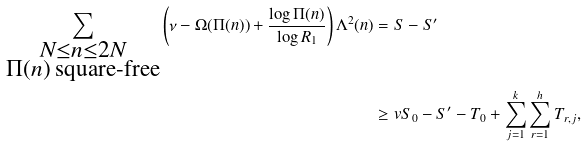<formula> <loc_0><loc_0><loc_500><loc_500>\sum _ { \substack { N \leq n \leq 2 N \\ \Pi ( n ) \text { square-free} } } \left ( \nu - \Omega ( \Pi ( n ) ) + \frac { \log { \Pi ( n ) } } { \log { R _ { 1 } } } \right ) \Lambda ^ { 2 } ( n ) & = S - S ^ { \prime } \\ & \geq v S _ { 0 } - S ^ { \prime } - T _ { 0 } + \sum _ { j = 1 } ^ { k } \sum _ { r = 1 } ^ { h } T _ { r , j } ,</formula> 